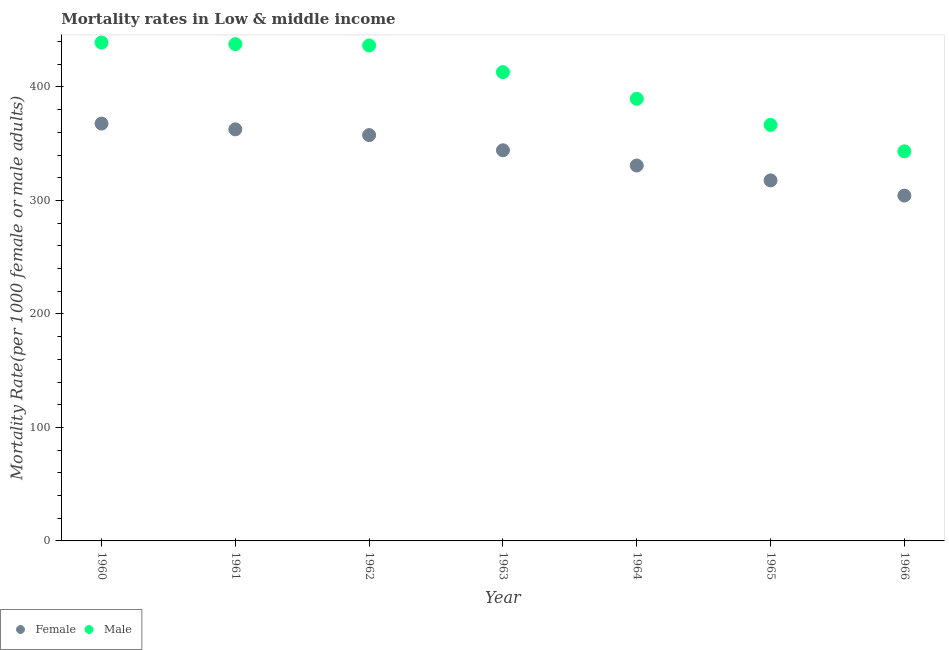How many different coloured dotlines are there?
Offer a terse response. 2. Is the number of dotlines equal to the number of legend labels?
Your response must be concise. Yes. What is the male mortality rate in 1963?
Your answer should be compact. 413.06. Across all years, what is the maximum female mortality rate?
Provide a succinct answer. 367.73. Across all years, what is the minimum female mortality rate?
Keep it short and to the point. 304.28. In which year was the male mortality rate minimum?
Ensure brevity in your answer.  1966. What is the total female mortality rate in the graph?
Provide a succinct answer. 2384.9. What is the difference between the female mortality rate in 1961 and that in 1963?
Provide a short and direct response. 18.47. What is the difference between the male mortality rate in 1963 and the female mortality rate in 1966?
Keep it short and to the point. 108.79. What is the average male mortality rate per year?
Give a very brief answer. 403.7. In the year 1963, what is the difference between the male mortality rate and female mortality rate?
Provide a short and direct response. 68.87. What is the ratio of the male mortality rate in 1961 to that in 1965?
Offer a terse response. 1.19. Is the male mortality rate in 1960 less than that in 1963?
Your answer should be very brief. No. Is the difference between the female mortality rate in 1960 and 1966 greater than the difference between the male mortality rate in 1960 and 1966?
Offer a terse response. No. What is the difference between the highest and the second highest female mortality rate?
Keep it short and to the point. 5.07. What is the difference between the highest and the lowest male mortality rate?
Your answer should be compact. 95.87. Is the male mortality rate strictly greater than the female mortality rate over the years?
Your response must be concise. Yes. Is the male mortality rate strictly less than the female mortality rate over the years?
Your answer should be compact. No. How many dotlines are there?
Offer a very short reply. 2. Does the graph contain any zero values?
Give a very brief answer. No. Does the graph contain grids?
Make the answer very short. No. Where does the legend appear in the graph?
Offer a terse response. Bottom left. How many legend labels are there?
Provide a short and direct response. 2. How are the legend labels stacked?
Provide a short and direct response. Horizontal. What is the title of the graph?
Your response must be concise. Mortality rates in Low & middle income. What is the label or title of the X-axis?
Provide a short and direct response. Year. What is the label or title of the Y-axis?
Offer a terse response. Mortality Rate(per 1000 female or male adults). What is the Mortality Rate(per 1000 female or male adults) in Female in 1960?
Your response must be concise. 367.73. What is the Mortality Rate(per 1000 female or male adults) in Male in 1960?
Keep it short and to the point. 439.14. What is the Mortality Rate(per 1000 female or male adults) of Female in 1961?
Your answer should be compact. 362.66. What is the Mortality Rate(per 1000 female or male adults) in Male in 1961?
Make the answer very short. 437.7. What is the Mortality Rate(per 1000 female or male adults) in Female in 1962?
Make the answer very short. 357.6. What is the Mortality Rate(per 1000 female or male adults) of Male in 1962?
Your answer should be very brief. 436.57. What is the Mortality Rate(per 1000 female or male adults) in Female in 1963?
Your response must be concise. 344.19. What is the Mortality Rate(per 1000 female or male adults) in Male in 1963?
Your answer should be compact. 413.06. What is the Mortality Rate(per 1000 female or male adults) of Female in 1964?
Your response must be concise. 330.79. What is the Mortality Rate(per 1000 female or male adults) in Male in 1964?
Offer a very short reply. 389.57. What is the Mortality Rate(per 1000 female or male adults) of Female in 1965?
Ensure brevity in your answer.  317.66. What is the Mortality Rate(per 1000 female or male adults) in Male in 1965?
Your answer should be very brief. 366.55. What is the Mortality Rate(per 1000 female or male adults) in Female in 1966?
Offer a very short reply. 304.28. What is the Mortality Rate(per 1000 female or male adults) of Male in 1966?
Keep it short and to the point. 343.27. Across all years, what is the maximum Mortality Rate(per 1000 female or male adults) of Female?
Your answer should be compact. 367.73. Across all years, what is the maximum Mortality Rate(per 1000 female or male adults) in Male?
Provide a short and direct response. 439.14. Across all years, what is the minimum Mortality Rate(per 1000 female or male adults) in Female?
Your response must be concise. 304.28. Across all years, what is the minimum Mortality Rate(per 1000 female or male adults) of Male?
Give a very brief answer. 343.27. What is the total Mortality Rate(per 1000 female or male adults) in Female in the graph?
Your answer should be compact. 2384.9. What is the total Mortality Rate(per 1000 female or male adults) in Male in the graph?
Your response must be concise. 2825.88. What is the difference between the Mortality Rate(per 1000 female or male adults) in Female in 1960 and that in 1961?
Provide a short and direct response. 5.07. What is the difference between the Mortality Rate(per 1000 female or male adults) in Male in 1960 and that in 1961?
Provide a short and direct response. 1.44. What is the difference between the Mortality Rate(per 1000 female or male adults) in Female in 1960 and that in 1962?
Provide a succinct answer. 10.13. What is the difference between the Mortality Rate(per 1000 female or male adults) in Male in 1960 and that in 1962?
Provide a short and direct response. 2.58. What is the difference between the Mortality Rate(per 1000 female or male adults) in Female in 1960 and that in 1963?
Your answer should be very brief. 23.54. What is the difference between the Mortality Rate(per 1000 female or male adults) in Male in 1960 and that in 1963?
Your response must be concise. 26.08. What is the difference between the Mortality Rate(per 1000 female or male adults) in Female in 1960 and that in 1964?
Give a very brief answer. 36.94. What is the difference between the Mortality Rate(per 1000 female or male adults) of Male in 1960 and that in 1964?
Your answer should be compact. 49.58. What is the difference between the Mortality Rate(per 1000 female or male adults) of Female in 1960 and that in 1965?
Make the answer very short. 50.07. What is the difference between the Mortality Rate(per 1000 female or male adults) of Male in 1960 and that in 1965?
Offer a very short reply. 72.59. What is the difference between the Mortality Rate(per 1000 female or male adults) in Female in 1960 and that in 1966?
Provide a succinct answer. 63.45. What is the difference between the Mortality Rate(per 1000 female or male adults) of Male in 1960 and that in 1966?
Provide a short and direct response. 95.87. What is the difference between the Mortality Rate(per 1000 female or male adults) of Female in 1961 and that in 1962?
Give a very brief answer. 5.06. What is the difference between the Mortality Rate(per 1000 female or male adults) in Male in 1961 and that in 1962?
Make the answer very short. 1.13. What is the difference between the Mortality Rate(per 1000 female or male adults) in Female in 1961 and that in 1963?
Your answer should be very brief. 18.47. What is the difference between the Mortality Rate(per 1000 female or male adults) of Male in 1961 and that in 1963?
Offer a very short reply. 24.64. What is the difference between the Mortality Rate(per 1000 female or male adults) in Female in 1961 and that in 1964?
Keep it short and to the point. 31.87. What is the difference between the Mortality Rate(per 1000 female or male adults) in Male in 1961 and that in 1964?
Your response must be concise. 48.13. What is the difference between the Mortality Rate(per 1000 female or male adults) of Female in 1961 and that in 1965?
Your answer should be compact. 45. What is the difference between the Mortality Rate(per 1000 female or male adults) in Male in 1961 and that in 1965?
Provide a short and direct response. 71.15. What is the difference between the Mortality Rate(per 1000 female or male adults) in Female in 1961 and that in 1966?
Your answer should be compact. 58.38. What is the difference between the Mortality Rate(per 1000 female or male adults) in Male in 1961 and that in 1966?
Provide a short and direct response. 94.43. What is the difference between the Mortality Rate(per 1000 female or male adults) of Female in 1962 and that in 1963?
Make the answer very short. 13.4. What is the difference between the Mortality Rate(per 1000 female or male adults) in Male in 1962 and that in 1963?
Provide a short and direct response. 23.51. What is the difference between the Mortality Rate(per 1000 female or male adults) of Female in 1962 and that in 1964?
Your answer should be very brief. 26.81. What is the difference between the Mortality Rate(per 1000 female or male adults) of Male in 1962 and that in 1964?
Your response must be concise. 47. What is the difference between the Mortality Rate(per 1000 female or male adults) of Female in 1962 and that in 1965?
Provide a short and direct response. 39.93. What is the difference between the Mortality Rate(per 1000 female or male adults) of Male in 1962 and that in 1965?
Your answer should be compact. 70.02. What is the difference between the Mortality Rate(per 1000 female or male adults) in Female in 1962 and that in 1966?
Your answer should be compact. 53.32. What is the difference between the Mortality Rate(per 1000 female or male adults) in Male in 1962 and that in 1966?
Offer a terse response. 93.29. What is the difference between the Mortality Rate(per 1000 female or male adults) in Female in 1963 and that in 1964?
Your answer should be compact. 13.4. What is the difference between the Mortality Rate(per 1000 female or male adults) of Male in 1963 and that in 1964?
Give a very brief answer. 23.5. What is the difference between the Mortality Rate(per 1000 female or male adults) in Female in 1963 and that in 1965?
Your response must be concise. 26.53. What is the difference between the Mortality Rate(per 1000 female or male adults) of Male in 1963 and that in 1965?
Your answer should be very brief. 46.51. What is the difference between the Mortality Rate(per 1000 female or male adults) in Female in 1963 and that in 1966?
Provide a short and direct response. 39.92. What is the difference between the Mortality Rate(per 1000 female or male adults) in Male in 1963 and that in 1966?
Your answer should be compact. 69.79. What is the difference between the Mortality Rate(per 1000 female or male adults) in Female in 1964 and that in 1965?
Give a very brief answer. 13.12. What is the difference between the Mortality Rate(per 1000 female or male adults) of Male in 1964 and that in 1965?
Offer a very short reply. 23.02. What is the difference between the Mortality Rate(per 1000 female or male adults) of Female in 1964 and that in 1966?
Your response must be concise. 26.51. What is the difference between the Mortality Rate(per 1000 female or male adults) in Male in 1964 and that in 1966?
Provide a short and direct response. 46.29. What is the difference between the Mortality Rate(per 1000 female or male adults) of Female in 1965 and that in 1966?
Offer a very short reply. 13.39. What is the difference between the Mortality Rate(per 1000 female or male adults) of Male in 1965 and that in 1966?
Your answer should be very brief. 23.28. What is the difference between the Mortality Rate(per 1000 female or male adults) in Female in 1960 and the Mortality Rate(per 1000 female or male adults) in Male in 1961?
Offer a terse response. -69.97. What is the difference between the Mortality Rate(per 1000 female or male adults) of Female in 1960 and the Mortality Rate(per 1000 female or male adults) of Male in 1962?
Your answer should be very brief. -68.84. What is the difference between the Mortality Rate(per 1000 female or male adults) in Female in 1960 and the Mortality Rate(per 1000 female or male adults) in Male in 1963?
Make the answer very short. -45.34. What is the difference between the Mortality Rate(per 1000 female or male adults) in Female in 1960 and the Mortality Rate(per 1000 female or male adults) in Male in 1964?
Provide a succinct answer. -21.84. What is the difference between the Mortality Rate(per 1000 female or male adults) of Female in 1960 and the Mortality Rate(per 1000 female or male adults) of Male in 1965?
Make the answer very short. 1.18. What is the difference between the Mortality Rate(per 1000 female or male adults) in Female in 1960 and the Mortality Rate(per 1000 female or male adults) in Male in 1966?
Provide a succinct answer. 24.45. What is the difference between the Mortality Rate(per 1000 female or male adults) in Female in 1961 and the Mortality Rate(per 1000 female or male adults) in Male in 1962?
Offer a very short reply. -73.91. What is the difference between the Mortality Rate(per 1000 female or male adults) in Female in 1961 and the Mortality Rate(per 1000 female or male adults) in Male in 1963?
Make the answer very short. -50.41. What is the difference between the Mortality Rate(per 1000 female or male adults) in Female in 1961 and the Mortality Rate(per 1000 female or male adults) in Male in 1964?
Your answer should be very brief. -26.91. What is the difference between the Mortality Rate(per 1000 female or male adults) of Female in 1961 and the Mortality Rate(per 1000 female or male adults) of Male in 1965?
Your answer should be very brief. -3.89. What is the difference between the Mortality Rate(per 1000 female or male adults) of Female in 1961 and the Mortality Rate(per 1000 female or male adults) of Male in 1966?
Give a very brief answer. 19.38. What is the difference between the Mortality Rate(per 1000 female or male adults) in Female in 1962 and the Mortality Rate(per 1000 female or male adults) in Male in 1963?
Offer a very short reply. -55.47. What is the difference between the Mortality Rate(per 1000 female or male adults) in Female in 1962 and the Mortality Rate(per 1000 female or male adults) in Male in 1964?
Offer a very short reply. -31.97. What is the difference between the Mortality Rate(per 1000 female or male adults) of Female in 1962 and the Mortality Rate(per 1000 female or male adults) of Male in 1965?
Provide a short and direct response. -8.96. What is the difference between the Mortality Rate(per 1000 female or male adults) in Female in 1962 and the Mortality Rate(per 1000 female or male adults) in Male in 1966?
Ensure brevity in your answer.  14.32. What is the difference between the Mortality Rate(per 1000 female or male adults) in Female in 1963 and the Mortality Rate(per 1000 female or male adults) in Male in 1964?
Make the answer very short. -45.38. What is the difference between the Mortality Rate(per 1000 female or male adults) of Female in 1963 and the Mortality Rate(per 1000 female or male adults) of Male in 1965?
Give a very brief answer. -22.36. What is the difference between the Mortality Rate(per 1000 female or male adults) in Female in 1963 and the Mortality Rate(per 1000 female or male adults) in Male in 1966?
Your answer should be very brief. 0.92. What is the difference between the Mortality Rate(per 1000 female or male adults) in Female in 1964 and the Mortality Rate(per 1000 female or male adults) in Male in 1965?
Give a very brief answer. -35.77. What is the difference between the Mortality Rate(per 1000 female or male adults) of Female in 1964 and the Mortality Rate(per 1000 female or male adults) of Male in 1966?
Provide a succinct answer. -12.49. What is the difference between the Mortality Rate(per 1000 female or male adults) of Female in 1965 and the Mortality Rate(per 1000 female or male adults) of Male in 1966?
Give a very brief answer. -25.61. What is the average Mortality Rate(per 1000 female or male adults) of Female per year?
Make the answer very short. 340.7. What is the average Mortality Rate(per 1000 female or male adults) of Male per year?
Provide a succinct answer. 403.7. In the year 1960, what is the difference between the Mortality Rate(per 1000 female or male adults) of Female and Mortality Rate(per 1000 female or male adults) of Male?
Give a very brief answer. -71.42. In the year 1961, what is the difference between the Mortality Rate(per 1000 female or male adults) of Female and Mortality Rate(per 1000 female or male adults) of Male?
Ensure brevity in your answer.  -75.05. In the year 1962, what is the difference between the Mortality Rate(per 1000 female or male adults) of Female and Mortality Rate(per 1000 female or male adults) of Male?
Your answer should be very brief. -78.97. In the year 1963, what is the difference between the Mortality Rate(per 1000 female or male adults) of Female and Mortality Rate(per 1000 female or male adults) of Male?
Provide a succinct answer. -68.87. In the year 1964, what is the difference between the Mortality Rate(per 1000 female or male adults) of Female and Mortality Rate(per 1000 female or male adults) of Male?
Your answer should be very brief. -58.78. In the year 1965, what is the difference between the Mortality Rate(per 1000 female or male adults) of Female and Mortality Rate(per 1000 female or male adults) of Male?
Make the answer very short. -48.89. In the year 1966, what is the difference between the Mortality Rate(per 1000 female or male adults) of Female and Mortality Rate(per 1000 female or male adults) of Male?
Make the answer very short. -39. What is the ratio of the Mortality Rate(per 1000 female or male adults) of Female in 1960 to that in 1962?
Your answer should be compact. 1.03. What is the ratio of the Mortality Rate(per 1000 female or male adults) in Male in 1960 to that in 1962?
Provide a short and direct response. 1.01. What is the ratio of the Mortality Rate(per 1000 female or male adults) of Female in 1960 to that in 1963?
Your answer should be very brief. 1.07. What is the ratio of the Mortality Rate(per 1000 female or male adults) in Male in 1960 to that in 1963?
Your answer should be very brief. 1.06. What is the ratio of the Mortality Rate(per 1000 female or male adults) in Female in 1960 to that in 1964?
Your answer should be very brief. 1.11. What is the ratio of the Mortality Rate(per 1000 female or male adults) of Male in 1960 to that in 1964?
Make the answer very short. 1.13. What is the ratio of the Mortality Rate(per 1000 female or male adults) in Female in 1960 to that in 1965?
Provide a short and direct response. 1.16. What is the ratio of the Mortality Rate(per 1000 female or male adults) in Male in 1960 to that in 1965?
Offer a very short reply. 1.2. What is the ratio of the Mortality Rate(per 1000 female or male adults) of Female in 1960 to that in 1966?
Give a very brief answer. 1.21. What is the ratio of the Mortality Rate(per 1000 female or male adults) of Male in 1960 to that in 1966?
Provide a short and direct response. 1.28. What is the ratio of the Mortality Rate(per 1000 female or male adults) of Female in 1961 to that in 1962?
Offer a very short reply. 1.01. What is the ratio of the Mortality Rate(per 1000 female or male adults) in Male in 1961 to that in 1962?
Keep it short and to the point. 1. What is the ratio of the Mortality Rate(per 1000 female or male adults) of Female in 1961 to that in 1963?
Provide a short and direct response. 1.05. What is the ratio of the Mortality Rate(per 1000 female or male adults) of Male in 1961 to that in 1963?
Provide a succinct answer. 1.06. What is the ratio of the Mortality Rate(per 1000 female or male adults) of Female in 1961 to that in 1964?
Your answer should be very brief. 1.1. What is the ratio of the Mortality Rate(per 1000 female or male adults) of Male in 1961 to that in 1964?
Your answer should be very brief. 1.12. What is the ratio of the Mortality Rate(per 1000 female or male adults) in Female in 1961 to that in 1965?
Provide a short and direct response. 1.14. What is the ratio of the Mortality Rate(per 1000 female or male adults) in Male in 1961 to that in 1965?
Offer a very short reply. 1.19. What is the ratio of the Mortality Rate(per 1000 female or male adults) in Female in 1961 to that in 1966?
Provide a short and direct response. 1.19. What is the ratio of the Mortality Rate(per 1000 female or male adults) of Male in 1961 to that in 1966?
Offer a terse response. 1.28. What is the ratio of the Mortality Rate(per 1000 female or male adults) in Female in 1962 to that in 1963?
Provide a succinct answer. 1.04. What is the ratio of the Mortality Rate(per 1000 female or male adults) of Male in 1962 to that in 1963?
Provide a short and direct response. 1.06. What is the ratio of the Mortality Rate(per 1000 female or male adults) of Female in 1962 to that in 1964?
Your answer should be compact. 1.08. What is the ratio of the Mortality Rate(per 1000 female or male adults) of Male in 1962 to that in 1964?
Make the answer very short. 1.12. What is the ratio of the Mortality Rate(per 1000 female or male adults) in Female in 1962 to that in 1965?
Your response must be concise. 1.13. What is the ratio of the Mortality Rate(per 1000 female or male adults) of Male in 1962 to that in 1965?
Keep it short and to the point. 1.19. What is the ratio of the Mortality Rate(per 1000 female or male adults) of Female in 1962 to that in 1966?
Provide a short and direct response. 1.18. What is the ratio of the Mortality Rate(per 1000 female or male adults) in Male in 1962 to that in 1966?
Your answer should be very brief. 1.27. What is the ratio of the Mortality Rate(per 1000 female or male adults) of Female in 1963 to that in 1964?
Make the answer very short. 1.04. What is the ratio of the Mortality Rate(per 1000 female or male adults) in Male in 1963 to that in 1964?
Your answer should be compact. 1.06. What is the ratio of the Mortality Rate(per 1000 female or male adults) in Female in 1963 to that in 1965?
Your answer should be very brief. 1.08. What is the ratio of the Mortality Rate(per 1000 female or male adults) of Male in 1963 to that in 1965?
Give a very brief answer. 1.13. What is the ratio of the Mortality Rate(per 1000 female or male adults) in Female in 1963 to that in 1966?
Provide a succinct answer. 1.13. What is the ratio of the Mortality Rate(per 1000 female or male adults) of Male in 1963 to that in 1966?
Your answer should be very brief. 1.2. What is the ratio of the Mortality Rate(per 1000 female or male adults) of Female in 1964 to that in 1965?
Provide a short and direct response. 1.04. What is the ratio of the Mortality Rate(per 1000 female or male adults) in Male in 1964 to that in 1965?
Make the answer very short. 1.06. What is the ratio of the Mortality Rate(per 1000 female or male adults) in Female in 1964 to that in 1966?
Keep it short and to the point. 1.09. What is the ratio of the Mortality Rate(per 1000 female or male adults) of Male in 1964 to that in 1966?
Provide a short and direct response. 1.13. What is the ratio of the Mortality Rate(per 1000 female or male adults) of Female in 1965 to that in 1966?
Offer a terse response. 1.04. What is the ratio of the Mortality Rate(per 1000 female or male adults) of Male in 1965 to that in 1966?
Your response must be concise. 1.07. What is the difference between the highest and the second highest Mortality Rate(per 1000 female or male adults) in Female?
Offer a very short reply. 5.07. What is the difference between the highest and the second highest Mortality Rate(per 1000 female or male adults) of Male?
Keep it short and to the point. 1.44. What is the difference between the highest and the lowest Mortality Rate(per 1000 female or male adults) of Female?
Keep it short and to the point. 63.45. What is the difference between the highest and the lowest Mortality Rate(per 1000 female or male adults) in Male?
Keep it short and to the point. 95.87. 